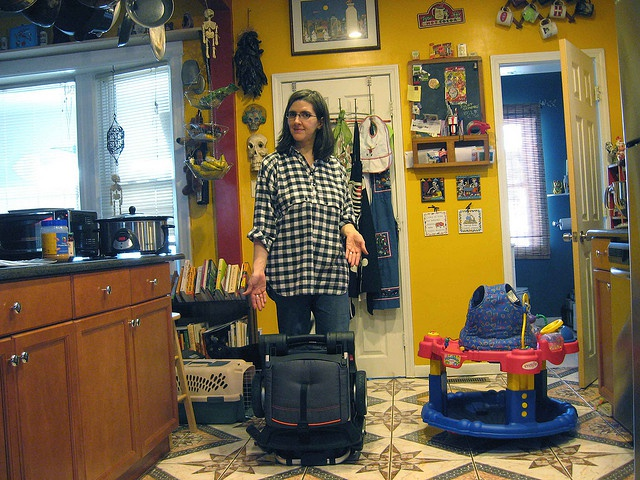Describe the objects in this image and their specific colors. I can see people in black, gray, darkgray, and tan tones, refrigerator in black, olive, and gray tones, book in black, tan, gray, and olive tones, microwave in black, navy, blue, and gray tones, and bottle in black, blue, olive, and gray tones in this image. 